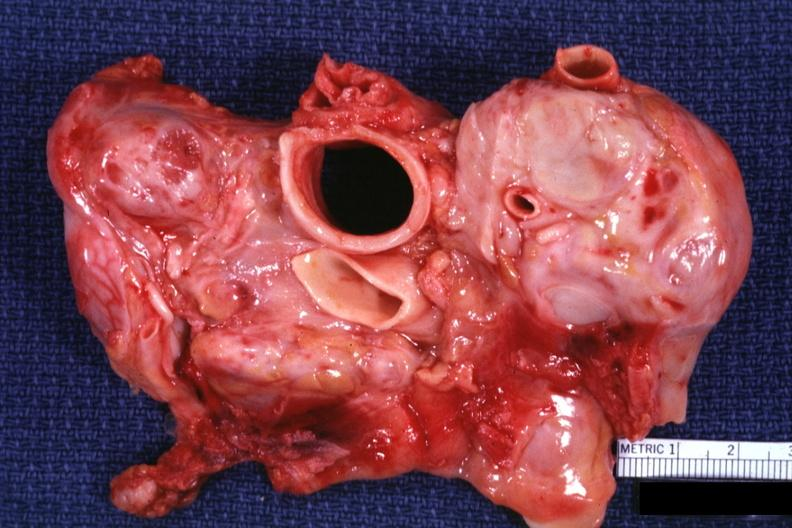what is present?
Answer the question using a single word or phrase. Lymph node 